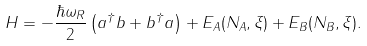<formula> <loc_0><loc_0><loc_500><loc_500>H = - \frac { \hbar { \omega } _ { R } } { 2 } \left ( a ^ { \dagger } b + b ^ { \dagger } a \right ) + E _ { A } ( N _ { A } , \xi ) + E _ { B } ( N _ { B } , \xi ) .</formula> 